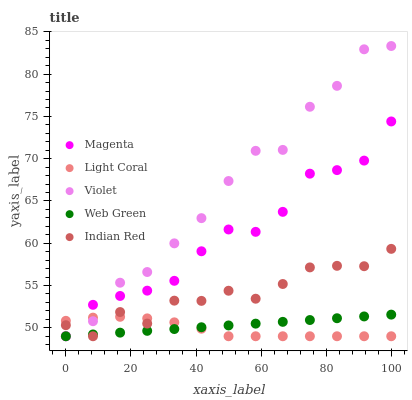Does Light Coral have the minimum area under the curve?
Answer yes or no. Yes. Does Violet have the maximum area under the curve?
Answer yes or no. Yes. Does Magenta have the minimum area under the curve?
Answer yes or no. No. Does Magenta have the maximum area under the curve?
Answer yes or no. No. Is Web Green the smoothest?
Answer yes or no. Yes. Is Violet the roughest?
Answer yes or no. Yes. Is Magenta the smoothest?
Answer yes or no. No. Is Magenta the roughest?
Answer yes or no. No. Does Light Coral have the lowest value?
Answer yes or no. Yes. Does Violet have the highest value?
Answer yes or no. Yes. Does Magenta have the highest value?
Answer yes or no. No. Does Light Coral intersect Violet?
Answer yes or no. Yes. Is Light Coral less than Violet?
Answer yes or no. No. Is Light Coral greater than Violet?
Answer yes or no. No. 